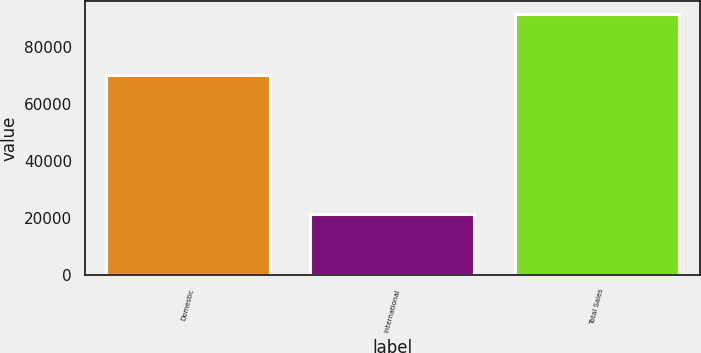Convert chart. <chart><loc_0><loc_0><loc_500><loc_500><bar_chart><fcel>Domestic<fcel>International<fcel>Total Sales<nl><fcel>70070<fcel>21605<fcel>91675<nl></chart> 